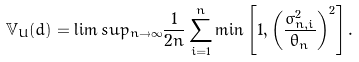<formula> <loc_0><loc_0><loc_500><loc_500>\mathbb { V } _ { U } ( d ) = \lim s u p _ { n \rightarrow \infty } \frac { 1 } { 2 n } \sum _ { i = 1 } ^ { n } \min \left [ 1 , \left ( \frac { \sigma _ { n , i } ^ { 2 } } { \theta _ { n } } \right ) ^ { 2 } \right ] .</formula> 